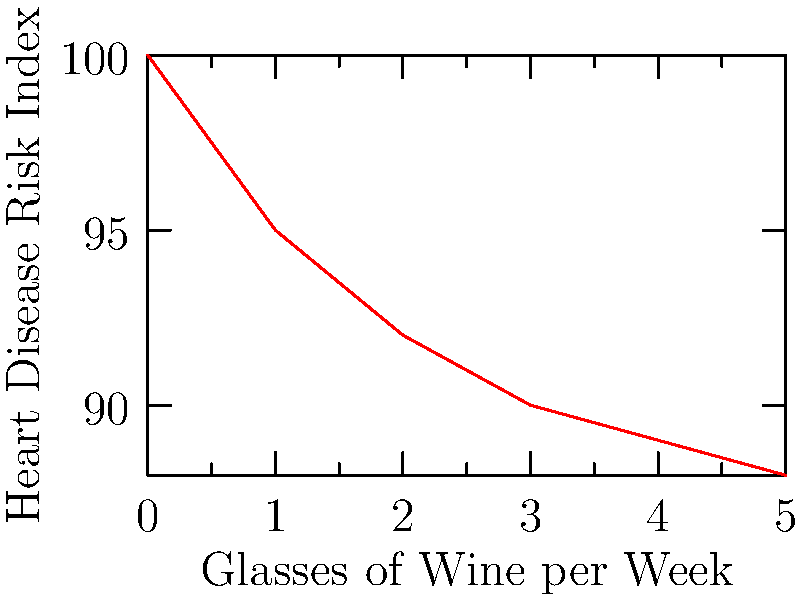Based on the line graph showing the relationship between weekly wine consumption and heart disease risk, what is the approximate reduction in heart disease risk index when increasing wine consumption from 0 to 2 glasses per week? To answer this question, we need to follow these steps:

1. Identify the heart disease risk index at 0 glasses of wine per week:
   At 0 glasses, the risk index is 100.

2. Identify the heart disease risk index at 2 glasses of wine per week:
   At 2 glasses, the risk index is approximately 92.

3. Calculate the difference between these two values:
   $\text{Difference} = 100 - 92 = 8$

4. Express this difference as an approximate reduction:
   The reduction is approximately 8 points on the heart disease risk index.

This data suggests that moderate wine consumption (2 glasses per week) is associated with a lower heart disease risk compared to no wine consumption. However, it's important to note that this is an observational relationship and doesn't necessarily imply causation. Other factors, such as overall diet and lifestyle, may also contribute to this association.
Answer: 8 points 